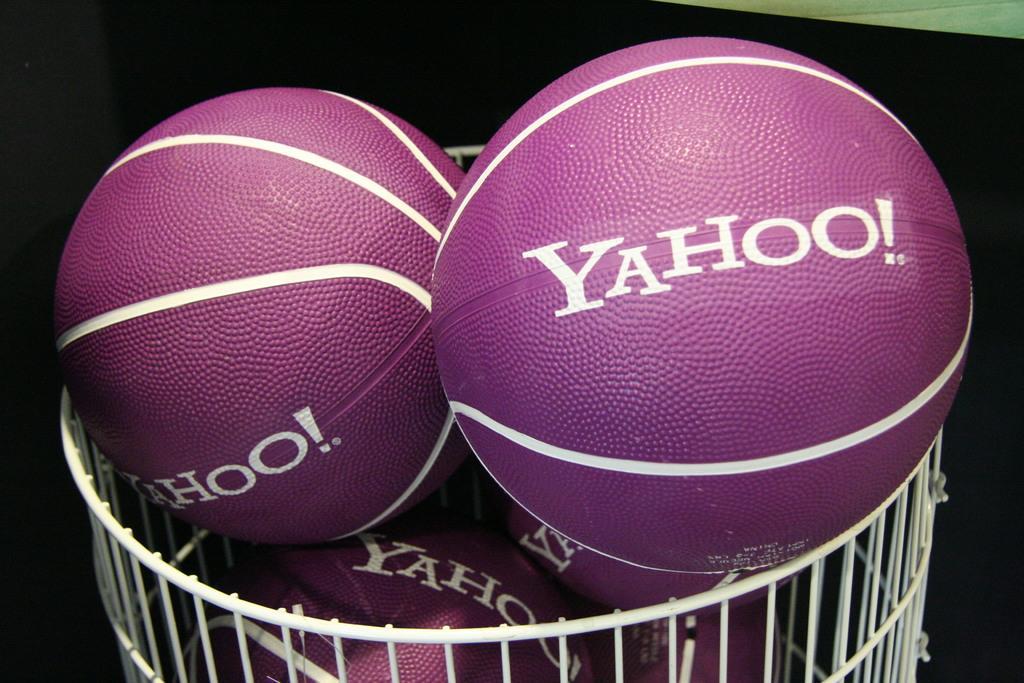Can you describe this image briefly? This image is taken indoors. In this image the background is dark. In the middle of the image there is a basket with a few balls in it. 